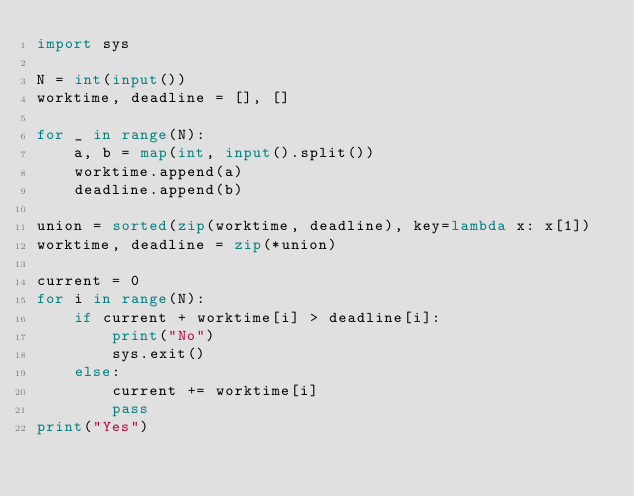Convert code to text. <code><loc_0><loc_0><loc_500><loc_500><_Python_>import sys

N = int(input())
worktime, deadline = [], []

for _ in range(N):
    a, b = map(int, input().split())
    worktime.append(a)
    deadline.append(b)

union = sorted(zip(worktime, deadline), key=lambda x: x[1])
worktime, deadline = zip(*union)

current = 0
for i in range(N):
    if current + worktime[i] > deadline[i]:
        print("No")
        sys.exit()
    else:
        current += worktime[i]
        pass
print("Yes")
    
    </code> 